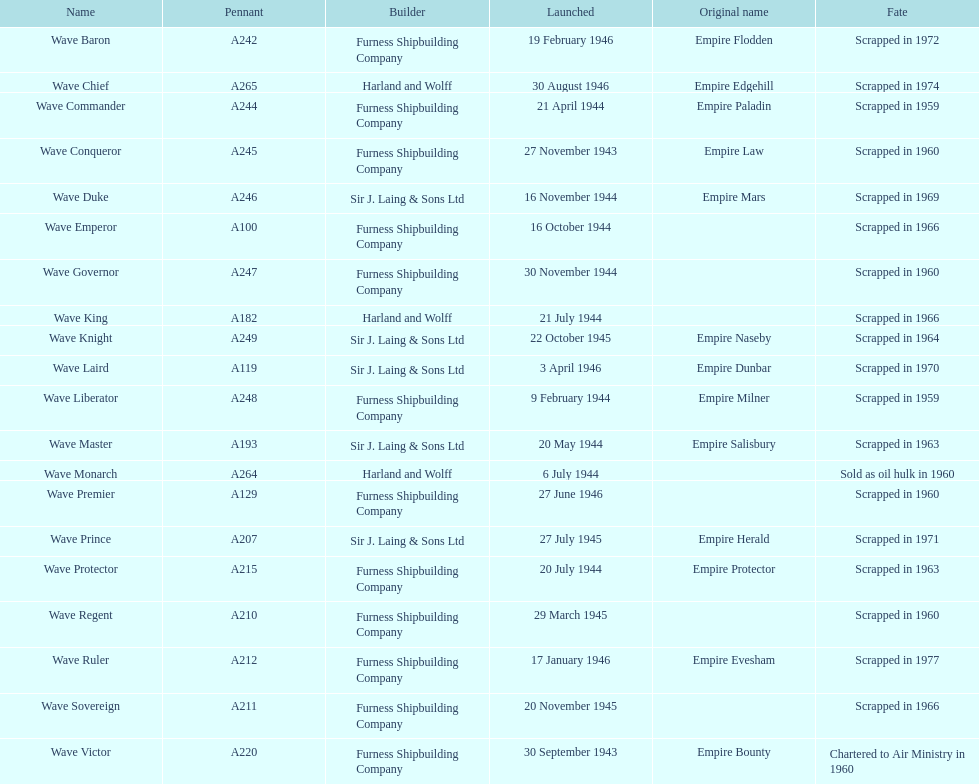What was the next wave class oiler after wave emperor? Wave Duke. 